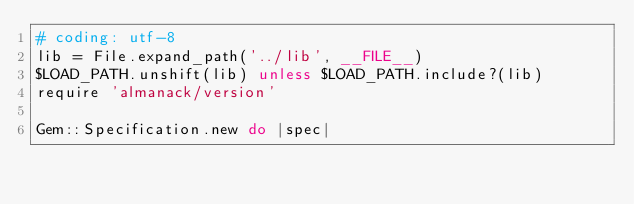Convert code to text. <code><loc_0><loc_0><loc_500><loc_500><_Ruby_># coding: utf-8
lib = File.expand_path('../lib', __FILE__)
$LOAD_PATH.unshift(lib) unless $LOAD_PATH.include?(lib)
require 'almanack/version'

Gem::Specification.new do |spec|</code> 